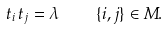Convert formula to latex. <formula><loc_0><loc_0><loc_500><loc_500>t _ { i } \, t _ { j } = \lambda \quad \{ i , j \} \in M .</formula> 